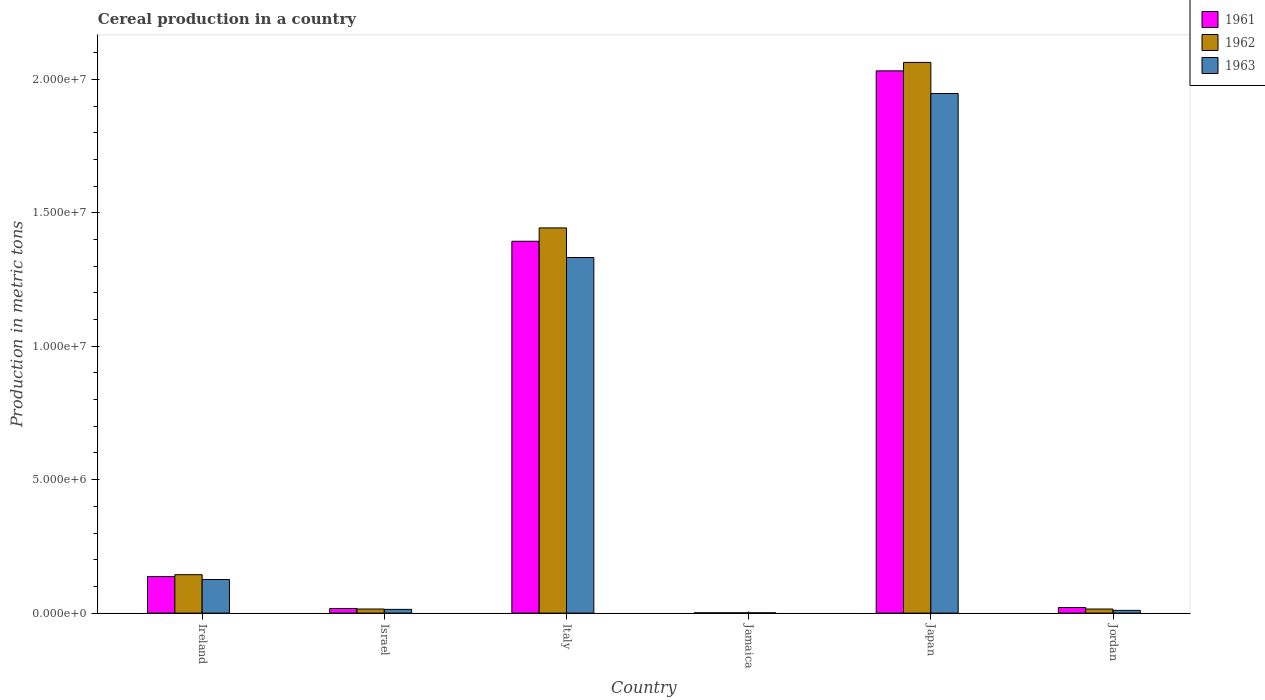How many groups of bars are there?
Provide a succinct answer. 6. Are the number of bars per tick equal to the number of legend labels?
Your response must be concise. Yes. Are the number of bars on each tick of the X-axis equal?
Provide a succinct answer. Yes. What is the label of the 3rd group of bars from the left?
Your response must be concise. Italy. What is the total cereal production in 1962 in Italy?
Your answer should be very brief. 1.44e+07. Across all countries, what is the maximum total cereal production in 1963?
Provide a succinct answer. 1.95e+07. Across all countries, what is the minimum total cereal production in 1963?
Provide a succinct answer. 9530. In which country was the total cereal production in 1962 minimum?
Ensure brevity in your answer.  Jamaica. What is the total total cereal production in 1963 in the graph?
Your answer should be compact. 3.43e+07. What is the difference between the total cereal production in 1962 in Ireland and that in Jamaica?
Provide a short and direct response. 1.43e+06. What is the difference between the total cereal production in 1963 in Jamaica and the total cereal production in 1962 in Jordan?
Make the answer very short. -1.43e+05. What is the average total cereal production in 1963 per country?
Your answer should be compact. 5.72e+06. What is the difference between the total cereal production of/in 1961 and total cereal production of/in 1963 in Jamaica?
Offer a terse response. -1097. In how many countries, is the total cereal production in 1961 greater than 17000000 metric tons?
Provide a short and direct response. 1. What is the ratio of the total cereal production in 1962 in Jamaica to that in Jordan?
Your answer should be very brief. 0.06. What is the difference between the highest and the second highest total cereal production in 1963?
Keep it short and to the point. -1.21e+07. What is the difference between the highest and the lowest total cereal production in 1962?
Your answer should be compact. 2.06e+07. What does the 2nd bar from the right in Japan represents?
Your answer should be compact. 1962. How many bars are there?
Your response must be concise. 18. Are all the bars in the graph horizontal?
Offer a terse response. No. How many countries are there in the graph?
Give a very brief answer. 6. Are the values on the major ticks of Y-axis written in scientific E-notation?
Provide a succinct answer. Yes. Does the graph contain any zero values?
Ensure brevity in your answer.  No. Does the graph contain grids?
Your response must be concise. No. What is the title of the graph?
Your response must be concise. Cereal production in a country. What is the label or title of the X-axis?
Ensure brevity in your answer.  Country. What is the label or title of the Y-axis?
Keep it short and to the point. Production in metric tons. What is the Production in metric tons in 1961 in Ireland?
Make the answer very short. 1.37e+06. What is the Production in metric tons in 1962 in Ireland?
Provide a short and direct response. 1.44e+06. What is the Production in metric tons in 1963 in Ireland?
Your answer should be compact. 1.26e+06. What is the Production in metric tons of 1961 in Israel?
Make the answer very short. 1.72e+05. What is the Production in metric tons of 1962 in Israel?
Provide a succinct answer. 1.53e+05. What is the Production in metric tons in 1963 in Israel?
Offer a terse response. 1.39e+05. What is the Production in metric tons in 1961 in Italy?
Give a very brief answer. 1.39e+07. What is the Production in metric tons of 1962 in Italy?
Ensure brevity in your answer.  1.44e+07. What is the Production in metric tons in 1963 in Italy?
Offer a terse response. 1.33e+07. What is the Production in metric tons in 1961 in Jamaica?
Offer a very short reply. 8433. What is the Production in metric tons of 1962 in Jamaica?
Make the answer very short. 8941. What is the Production in metric tons in 1963 in Jamaica?
Offer a very short reply. 9530. What is the Production in metric tons in 1961 in Japan?
Keep it short and to the point. 2.03e+07. What is the Production in metric tons of 1962 in Japan?
Ensure brevity in your answer.  2.06e+07. What is the Production in metric tons of 1963 in Japan?
Give a very brief answer. 1.95e+07. What is the Production in metric tons of 1961 in Jordan?
Your answer should be compact. 2.08e+05. What is the Production in metric tons of 1962 in Jordan?
Offer a very short reply. 1.53e+05. What is the Production in metric tons of 1963 in Jordan?
Your answer should be very brief. 1.02e+05. Across all countries, what is the maximum Production in metric tons of 1961?
Your answer should be compact. 2.03e+07. Across all countries, what is the maximum Production in metric tons of 1962?
Offer a very short reply. 2.06e+07. Across all countries, what is the maximum Production in metric tons in 1963?
Your response must be concise. 1.95e+07. Across all countries, what is the minimum Production in metric tons in 1961?
Provide a succinct answer. 8433. Across all countries, what is the minimum Production in metric tons of 1962?
Your answer should be compact. 8941. Across all countries, what is the minimum Production in metric tons of 1963?
Provide a succinct answer. 9530. What is the total Production in metric tons in 1961 in the graph?
Provide a short and direct response. 3.60e+07. What is the total Production in metric tons of 1962 in the graph?
Make the answer very short. 3.68e+07. What is the total Production in metric tons of 1963 in the graph?
Provide a succinct answer. 3.43e+07. What is the difference between the Production in metric tons of 1961 in Ireland and that in Israel?
Give a very brief answer. 1.20e+06. What is the difference between the Production in metric tons in 1962 in Ireland and that in Israel?
Ensure brevity in your answer.  1.29e+06. What is the difference between the Production in metric tons of 1963 in Ireland and that in Israel?
Keep it short and to the point. 1.12e+06. What is the difference between the Production in metric tons in 1961 in Ireland and that in Italy?
Make the answer very short. -1.26e+07. What is the difference between the Production in metric tons of 1962 in Ireland and that in Italy?
Provide a succinct answer. -1.30e+07. What is the difference between the Production in metric tons in 1963 in Ireland and that in Italy?
Ensure brevity in your answer.  -1.21e+07. What is the difference between the Production in metric tons of 1961 in Ireland and that in Jamaica?
Offer a terse response. 1.36e+06. What is the difference between the Production in metric tons in 1962 in Ireland and that in Jamaica?
Provide a short and direct response. 1.43e+06. What is the difference between the Production in metric tons in 1963 in Ireland and that in Jamaica?
Offer a terse response. 1.25e+06. What is the difference between the Production in metric tons of 1961 in Ireland and that in Japan?
Keep it short and to the point. -1.90e+07. What is the difference between the Production in metric tons of 1962 in Ireland and that in Japan?
Your answer should be very brief. -1.92e+07. What is the difference between the Production in metric tons in 1963 in Ireland and that in Japan?
Your answer should be very brief. -1.82e+07. What is the difference between the Production in metric tons of 1961 in Ireland and that in Jordan?
Make the answer very short. 1.16e+06. What is the difference between the Production in metric tons of 1962 in Ireland and that in Jordan?
Make the answer very short. 1.29e+06. What is the difference between the Production in metric tons in 1963 in Ireland and that in Jordan?
Your response must be concise. 1.16e+06. What is the difference between the Production in metric tons of 1961 in Israel and that in Italy?
Offer a very short reply. -1.38e+07. What is the difference between the Production in metric tons of 1962 in Israel and that in Italy?
Give a very brief answer. -1.43e+07. What is the difference between the Production in metric tons in 1963 in Israel and that in Italy?
Provide a short and direct response. -1.32e+07. What is the difference between the Production in metric tons of 1961 in Israel and that in Jamaica?
Your answer should be compact. 1.63e+05. What is the difference between the Production in metric tons in 1962 in Israel and that in Jamaica?
Provide a short and direct response. 1.44e+05. What is the difference between the Production in metric tons in 1963 in Israel and that in Jamaica?
Ensure brevity in your answer.  1.30e+05. What is the difference between the Production in metric tons of 1961 in Israel and that in Japan?
Keep it short and to the point. -2.01e+07. What is the difference between the Production in metric tons in 1962 in Israel and that in Japan?
Ensure brevity in your answer.  -2.05e+07. What is the difference between the Production in metric tons in 1963 in Israel and that in Japan?
Give a very brief answer. -1.93e+07. What is the difference between the Production in metric tons of 1961 in Israel and that in Jordan?
Give a very brief answer. -3.64e+04. What is the difference between the Production in metric tons in 1962 in Israel and that in Jordan?
Provide a short and direct response. -201. What is the difference between the Production in metric tons in 1963 in Israel and that in Jordan?
Offer a terse response. 3.70e+04. What is the difference between the Production in metric tons of 1961 in Italy and that in Jamaica?
Your answer should be compact. 1.39e+07. What is the difference between the Production in metric tons of 1962 in Italy and that in Jamaica?
Keep it short and to the point. 1.44e+07. What is the difference between the Production in metric tons in 1963 in Italy and that in Jamaica?
Your response must be concise. 1.33e+07. What is the difference between the Production in metric tons in 1961 in Italy and that in Japan?
Provide a succinct answer. -6.39e+06. What is the difference between the Production in metric tons in 1962 in Italy and that in Japan?
Give a very brief answer. -6.20e+06. What is the difference between the Production in metric tons in 1963 in Italy and that in Japan?
Provide a short and direct response. -6.15e+06. What is the difference between the Production in metric tons in 1961 in Italy and that in Jordan?
Your response must be concise. 1.37e+07. What is the difference between the Production in metric tons of 1962 in Italy and that in Jordan?
Provide a short and direct response. 1.43e+07. What is the difference between the Production in metric tons in 1963 in Italy and that in Jordan?
Ensure brevity in your answer.  1.32e+07. What is the difference between the Production in metric tons of 1961 in Jamaica and that in Japan?
Provide a short and direct response. -2.03e+07. What is the difference between the Production in metric tons of 1962 in Jamaica and that in Japan?
Make the answer very short. -2.06e+07. What is the difference between the Production in metric tons in 1963 in Jamaica and that in Japan?
Make the answer very short. -1.95e+07. What is the difference between the Production in metric tons in 1961 in Jamaica and that in Jordan?
Your answer should be compact. -2.00e+05. What is the difference between the Production in metric tons in 1962 in Jamaica and that in Jordan?
Provide a short and direct response. -1.44e+05. What is the difference between the Production in metric tons of 1963 in Jamaica and that in Jordan?
Provide a short and direct response. -9.26e+04. What is the difference between the Production in metric tons of 1961 in Japan and that in Jordan?
Your answer should be very brief. 2.01e+07. What is the difference between the Production in metric tons in 1962 in Japan and that in Jordan?
Provide a short and direct response. 2.05e+07. What is the difference between the Production in metric tons in 1963 in Japan and that in Jordan?
Ensure brevity in your answer.  1.94e+07. What is the difference between the Production in metric tons of 1961 in Ireland and the Production in metric tons of 1962 in Israel?
Give a very brief answer. 1.22e+06. What is the difference between the Production in metric tons of 1961 in Ireland and the Production in metric tons of 1963 in Israel?
Provide a succinct answer. 1.23e+06. What is the difference between the Production in metric tons in 1962 in Ireland and the Production in metric tons in 1963 in Israel?
Make the answer very short. 1.30e+06. What is the difference between the Production in metric tons of 1961 in Ireland and the Production in metric tons of 1962 in Italy?
Provide a short and direct response. -1.31e+07. What is the difference between the Production in metric tons of 1961 in Ireland and the Production in metric tons of 1963 in Italy?
Give a very brief answer. -1.20e+07. What is the difference between the Production in metric tons of 1962 in Ireland and the Production in metric tons of 1963 in Italy?
Give a very brief answer. -1.19e+07. What is the difference between the Production in metric tons in 1961 in Ireland and the Production in metric tons in 1962 in Jamaica?
Keep it short and to the point. 1.36e+06. What is the difference between the Production in metric tons of 1961 in Ireland and the Production in metric tons of 1963 in Jamaica?
Give a very brief answer. 1.36e+06. What is the difference between the Production in metric tons in 1962 in Ireland and the Production in metric tons in 1963 in Jamaica?
Provide a succinct answer. 1.43e+06. What is the difference between the Production in metric tons in 1961 in Ireland and the Production in metric tons in 1962 in Japan?
Make the answer very short. -1.93e+07. What is the difference between the Production in metric tons in 1961 in Ireland and the Production in metric tons in 1963 in Japan?
Provide a short and direct response. -1.81e+07. What is the difference between the Production in metric tons in 1962 in Ireland and the Production in metric tons in 1963 in Japan?
Keep it short and to the point. -1.80e+07. What is the difference between the Production in metric tons of 1961 in Ireland and the Production in metric tons of 1962 in Jordan?
Provide a short and direct response. 1.22e+06. What is the difference between the Production in metric tons in 1961 in Ireland and the Production in metric tons in 1963 in Jordan?
Ensure brevity in your answer.  1.27e+06. What is the difference between the Production in metric tons in 1962 in Ireland and the Production in metric tons in 1963 in Jordan?
Offer a terse response. 1.34e+06. What is the difference between the Production in metric tons in 1961 in Israel and the Production in metric tons in 1962 in Italy?
Offer a terse response. -1.43e+07. What is the difference between the Production in metric tons in 1961 in Israel and the Production in metric tons in 1963 in Italy?
Provide a short and direct response. -1.32e+07. What is the difference between the Production in metric tons of 1962 in Israel and the Production in metric tons of 1963 in Italy?
Offer a terse response. -1.32e+07. What is the difference between the Production in metric tons of 1961 in Israel and the Production in metric tons of 1962 in Jamaica?
Offer a very short reply. 1.63e+05. What is the difference between the Production in metric tons in 1961 in Israel and the Production in metric tons in 1963 in Jamaica?
Provide a succinct answer. 1.62e+05. What is the difference between the Production in metric tons of 1962 in Israel and the Production in metric tons of 1963 in Jamaica?
Ensure brevity in your answer.  1.43e+05. What is the difference between the Production in metric tons in 1961 in Israel and the Production in metric tons in 1962 in Japan?
Your response must be concise. -2.05e+07. What is the difference between the Production in metric tons of 1961 in Israel and the Production in metric tons of 1963 in Japan?
Give a very brief answer. -1.93e+07. What is the difference between the Production in metric tons of 1962 in Israel and the Production in metric tons of 1963 in Japan?
Keep it short and to the point. -1.93e+07. What is the difference between the Production in metric tons in 1961 in Israel and the Production in metric tons in 1962 in Jordan?
Provide a short and direct response. 1.87e+04. What is the difference between the Production in metric tons of 1961 in Israel and the Production in metric tons of 1963 in Jordan?
Keep it short and to the point. 6.94e+04. What is the difference between the Production in metric tons in 1962 in Israel and the Production in metric tons in 1963 in Jordan?
Offer a very short reply. 5.05e+04. What is the difference between the Production in metric tons in 1961 in Italy and the Production in metric tons in 1962 in Jamaica?
Make the answer very short. 1.39e+07. What is the difference between the Production in metric tons in 1961 in Italy and the Production in metric tons in 1963 in Jamaica?
Your answer should be very brief. 1.39e+07. What is the difference between the Production in metric tons of 1962 in Italy and the Production in metric tons of 1963 in Jamaica?
Provide a short and direct response. 1.44e+07. What is the difference between the Production in metric tons of 1961 in Italy and the Production in metric tons of 1962 in Japan?
Make the answer very short. -6.70e+06. What is the difference between the Production in metric tons of 1961 in Italy and the Production in metric tons of 1963 in Japan?
Offer a terse response. -5.54e+06. What is the difference between the Production in metric tons of 1962 in Italy and the Production in metric tons of 1963 in Japan?
Keep it short and to the point. -5.04e+06. What is the difference between the Production in metric tons of 1961 in Italy and the Production in metric tons of 1962 in Jordan?
Your answer should be very brief. 1.38e+07. What is the difference between the Production in metric tons in 1961 in Italy and the Production in metric tons in 1963 in Jordan?
Your answer should be compact. 1.38e+07. What is the difference between the Production in metric tons in 1962 in Italy and the Production in metric tons in 1963 in Jordan?
Provide a succinct answer. 1.43e+07. What is the difference between the Production in metric tons of 1961 in Jamaica and the Production in metric tons of 1962 in Japan?
Provide a short and direct response. -2.06e+07. What is the difference between the Production in metric tons of 1961 in Jamaica and the Production in metric tons of 1963 in Japan?
Your response must be concise. -1.95e+07. What is the difference between the Production in metric tons of 1962 in Jamaica and the Production in metric tons of 1963 in Japan?
Your answer should be very brief. -1.95e+07. What is the difference between the Production in metric tons in 1961 in Jamaica and the Production in metric tons in 1962 in Jordan?
Ensure brevity in your answer.  -1.44e+05. What is the difference between the Production in metric tons of 1961 in Jamaica and the Production in metric tons of 1963 in Jordan?
Offer a very short reply. -9.37e+04. What is the difference between the Production in metric tons of 1962 in Jamaica and the Production in metric tons of 1963 in Jordan?
Offer a very short reply. -9.32e+04. What is the difference between the Production in metric tons in 1961 in Japan and the Production in metric tons in 1962 in Jordan?
Provide a short and direct response. 2.02e+07. What is the difference between the Production in metric tons of 1961 in Japan and the Production in metric tons of 1963 in Jordan?
Provide a short and direct response. 2.02e+07. What is the difference between the Production in metric tons in 1962 in Japan and the Production in metric tons in 1963 in Jordan?
Your answer should be compact. 2.05e+07. What is the average Production in metric tons of 1961 per country?
Provide a succinct answer. 6.00e+06. What is the average Production in metric tons of 1962 per country?
Your answer should be compact. 6.14e+06. What is the average Production in metric tons of 1963 per country?
Ensure brevity in your answer.  5.72e+06. What is the difference between the Production in metric tons of 1961 and Production in metric tons of 1962 in Ireland?
Keep it short and to the point. -7.13e+04. What is the difference between the Production in metric tons in 1961 and Production in metric tons in 1963 in Ireland?
Provide a short and direct response. 1.09e+05. What is the difference between the Production in metric tons in 1962 and Production in metric tons in 1963 in Ireland?
Provide a succinct answer. 1.80e+05. What is the difference between the Production in metric tons in 1961 and Production in metric tons in 1962 in Israel?
Offer a very short reply. 1.89e+04. What is the difference between the Production in metric tons in 1961 and Production in metric tons in 1963 in Israel?
Give a very brief answer. 3.24e+04. What is the difference between the Production in metric tons in 1962 and Production in metric tons in 1963 in Israel?
Ensure brevity in your answer.  1.35e+04. What is the difference between the Production in metric tons of 1961 and Production in metric tons of 1962 in Italy?
Offer a very short reply. -5.00e+05. What is the difference between the Production in metric tons of 1961 and Production in metric tons of 1963 in Italy?
Give a very brief answer. 6.09e+05. What is the difference between the Production in metric tons in 1962 and Production in metric tons in 1963 in Italy?
Provide a short and direct response. 1.11e+06. What is the difference between the Production in metric tons in 1961 and Production in metric tons in 1962 in Jamaica?
Your response must be concise. -508. What is the difference between the Production in metric tons of 1961 and Production in metric tons of 1963 in Jamaica?
Offer a very short reply. -1097. What is the difference between the Production in metric tons in 1962 and Production in metric tons in 1963 in Jamaica?
Ensure brevity in your answer.  -589. What is the difference between the Production in metric tons in 1961 and Production in metric tons in 1962 in Japan?
Provide a succinct answer. -3.16e+05. What is the difference between the Production in metric tons in 1961 and Production in metric tons in 1963 in Japan?
Keep it short and to the point. 8.48e+05. What is the difference between the Production in metric tons of 1962 and Production in metric tons of 1963 in Japan?
Your answer should be compact. 1.16e+06. What is the difference between the Production in metric tons of 1961 and Production in metric tons of 1962 in Jordan?
Provide a short and direct response. 5.51e+04. What is the difference between the Production in metric tons of 1961 and Production in metric tons of 1963 in Jordan?
Provide a succinct answer. 1.06e+05. What is the difference between the Production in metric tons in 1962 and Production in metric tons in 1963 in Jordan?
Your answer should be very brief. 5.07e+04. What is the ratio of the Production in metric tons of 1961 in Ireland to that in Israel?
Your answer should be compact. 7.97. What is the ratio of the Production in metric tons in 1962 in Ireland to that in Israel?
Offer a very short reply. 9.43. What is the ratio of the Production in metric tons of 1963 in Ireland to that in Israel?
Make the answer very short. 9.04. What is the ratio of the Production in metric tons of 1961 in Ireland to that in Italy?
Your answer should be compact. 0.1. What is the ratio of the Production in metric tons of 1962 in Ireland to that in Italy?
Keep it short and to the point. 0.1. What is the ratio of the Production in metric tons of 1963 in Ireland to that in Italy?
Ensure brevity in your answer.  0.09. What is the ratio of the Production in metric tons in 1961 in Ireland to that in Jamaica?
Your response must be concise. 162.21. What is the ratio of the Production in metric tons in 1962 in Ireland to that in Jamaica?
Your answer should be very brief. 160.97. What is the ratio of the Production in metric tons of 1963 in Ireland to that in Jamaica?
Keep it short and to the point. 132.09. What is the ratio of the Production in metric tons in 1961 in Ireland to that in Japan?
Make the answer very short. 0.07. What is the ratio of the Production in metric tons in 1962 in Ireland to that in Japan?
Your response must be concise. 0.07. What is the ratio of the Production in metric tons of 1963 in Ireland to that in Japan?
Provide a short and direct response. 0.06. What is the ratio of the Production in metric tons of 1961 in Ireland to that in Jordan?
Offer a terse response. 6.58. What is the ratio of the Production in metric tons in 1962 in Ireland to that in Jordan?
Provide a short and direct response. 9.41. What is the ratio of the Production in metric tons of 1963 in Ireland to that in Jordan?
Ensure brevity in your answer.  12.32. What is the ratio of the Production in metric tons of 1961 in Israel to that in Italy?
Your answer should be compact. 0.01. What is the ratio of the Production in metric tons in 1962 in Israel to that in Italy?
Your response must be concise. 0.01. What is the ratio of the Production in metric tons of 1963 in Israel to that in Italy?
Offer a very short reply. 0.01. What is the ratio of the Production in metric tons in 1961 in Israel to that in Jamaica?
Keep it short and to the point. 20.35. What is the ratio of the Production in metric tons in 1962 in Israel to that in Jamaica?
Ensure brevity in your answer.  17.08. What is the ratio of the Production in metric tons in 1963 in Israel to that in Jamaica?
Provide a succinct answer. 14.61. What is the ratio of the Production in metric tons in 1961 in Israel to that in Japan?
Your answer should be compact. 0.01. What is the ratio of the Production in metric tons in 1962 in Israel to that in Japan?
Provide a succinct answer. 0.01. What is the ratio of the Production in metric tons of 1963 in Israel to that in Japan?
Offer a very short reply. 0.01. What is the ratio of the Production in metric tons of 1961 in Israel to that in Jordan?
Your answer should be compact. 0.82. What is the ratio of the Production in metric tons in 1963 in Israel to that in Jordan?
Provide a succinct answer. 1.36. What is the ratio of the Production in metric tons of 1961 in Italy to that in Jamaica?
Give a very brief answer. 1652.25. What is the ratio of the Production in metric tons in 1962 in Italy to that in Jamaica?
Your answer should be compact. 1614.27. What is the ratio of the Production in metric tons of 1963 in Italy to that in Jamaica?
Your answer should be compact. 1398.18. What is the ratio of the Production in metric tons in 1961 in Italy to that in Japan?
Give a very brief answer. 0.69. What is the ratio of the Production in metric tons in 1962 in Italy to that in Japan?
Ensure brevity in your answer.  0.7. What is the ratio of the Production in metric tons of 1963 in Italy to that in Japan?
Your answer should be compact. 0.68. What is the ratio of the Production in metric tons in 1961 in Italy to that in Jordan?
Keep it short and to the point. 66.99. What is the ratio of the Production in metric tons of 1962 in Italy to that in Jordan?
Keep it short and to the point. 94.4. What is the ratio of the Production in metric tons of 1963 in Italy to that in Jordan?
Offer a very short reply. 130.42. What is the ratio of the Production in metric tons of 1961 in Jamaica to that in Jordan?
Give a very brief answer. 0.04. What is the ratio of the Production in metric tons of 1962 in Jamaica to that in Jordan?
Provide a succinct answer. 0.06. What is the ratio of the Production in metric tons in 1963 in Jamaica to that in Jordan?
Your answer should be compact. 0.09. What is the ratio of the Production in metric tons in 1961 in Japan to that in Jordan?
Your response must be concise. 97.68. What is the ratio of the Production in metric tons in 1962 in Japan to that in Jordan?
Give a very brief answer. 134.96. What is the ratio of the Production in metric tons in 1963 in Japan to that in Jordan?
Provide a short and direct response. 190.58. What is the difference between the highest and the second highest Production in metric tons of 1961?
Provide a short and direct response. 6.39e+06. What is the difference between the highest and the second highest Production in metric tons of 1962?
Offer a very short reply. 6.20e+06. What is the difference between the highest and the second highest Production in metric tons in 1963?
Your response must be concise. 6.15e+06. What is the difference between the highest and the lowest Production in metric tons in 1961?
Keep it short and to the point. 2.03e+07. What is the difference between the highest and the lowest Production in metric tons in 1962?
Your answer should be very brief. 2.06e+07. What is the difference between the highest and the lowest Production in metric tons in 1963?
Provide a succinct answer. 1.95e+07. 